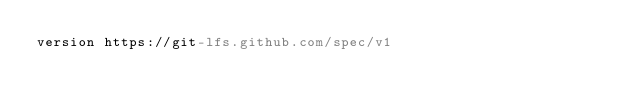<code> <loc_0><loc_0><loc_500><loc_500><_YAML_>version https://git-lfs.github.com/spec/v1</code> 